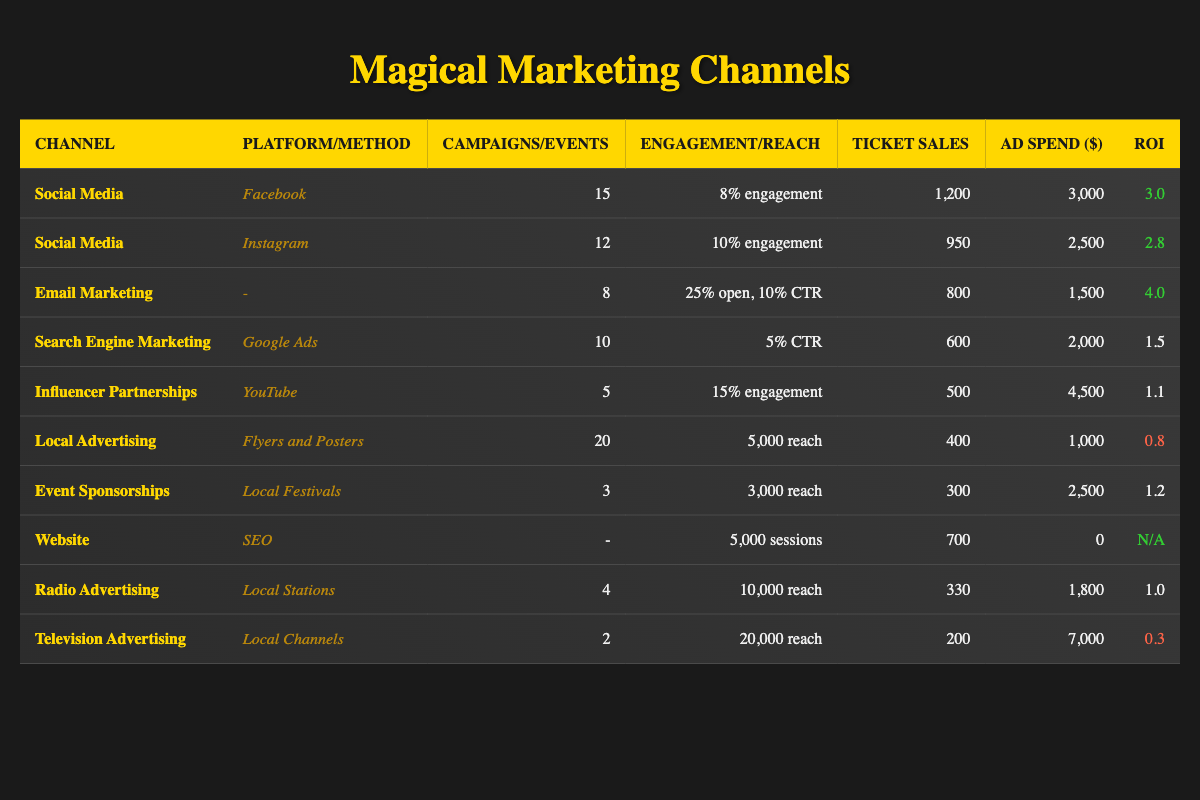What's the total amount spent on radio advertising? The table shows that the ad spend for radio advertising is $1,800.
Answer: 1,800 Which social media platform generated the highest ticket sales? In the table, Facebook generated 1,200 ticket sales, which is higher than Instagram's 950.
Answer: Facebook What is the total number of campaigns run across all marketing channels? By summing the campaigns from all channels (15 + 12 + 8 + 10 + 5 + 20 + 3 + 0 + 4 + 2 = 89), we find there were 89 campaigns in total.
Answer: 89 Is the return on investment (ROI) for email marketing greater than 4? The ROI for email marketing is 4.0, which is not greater than 4.0, so the statement is false.
Answer: No What is the average ticket sales generated from the marketing channels with the highest ROI? The highest ROIs are from email marketing (4.0), social media platforms (3.0, 2.8), and the website (N/A). Adding their ticket sales (800 + 1200 + 950 + 700 = 2,650) and dividing by 3 gives an average of 883.33.
Answer: 883.33 Which marketing channel had the lowest ROI? The table indicates that television advertising had the lowest ROI at 0.3.
Answer: 0.3 Did local advertising reach more people than influencer partnerships? Local advertising had a reach of 5,000, while influencer partnerships reached 3,000 people, making the statement true.
Answer: Yes What is the total ticket sales generated from the marketing channels with an engagement rate greater than 8%? The channels with engagement rates greater than 8% are Facebook (1,200), Instagram (950), and influencer partnerships (500). Summing these ticket sales (1,200 + 950 + 500 = 2,650) provides a total of 2,650.
Answer: 2,650 How much did the television advertising cost in relation to the number of ticket sales generated? The television advertising cost $7,000 for 200 ticket sales, giving a cost of 35 per ticket sale, calculated as 7,000/200.
Answer: 35 What is the difference in ticket sales generated between the social media channels and the email marketing channel? The ticket sales from social media channels (Facebook + Instagram = 1,200 + 950 = 2,150) minus email marketing ticket sales (800) equals 1,350, calculated as 2,150 - 800.
Answer: 1,350 